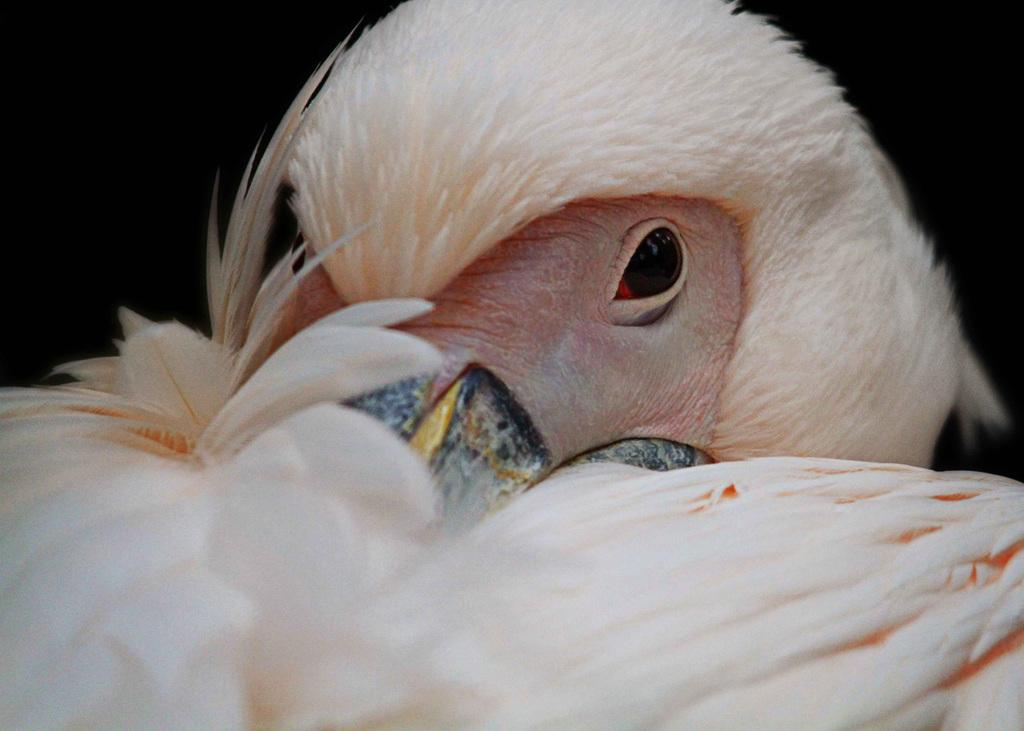What is the main subject of the image? There is a bird in the center of the image. Can you describe the bird in the image? The bird is the main focus of the image, but no specific details about its appearance are provided. What is the bird's position in the image? The bird is in the center of the image. What type of disgust can be seen on the bird's face in the image? There is no indication of any emotion, including disgust, on the bird's face in the image. What does the bird's mom look like in the image? There is no mention of the bird's mom in the image, so we cannot describe her appearance. 